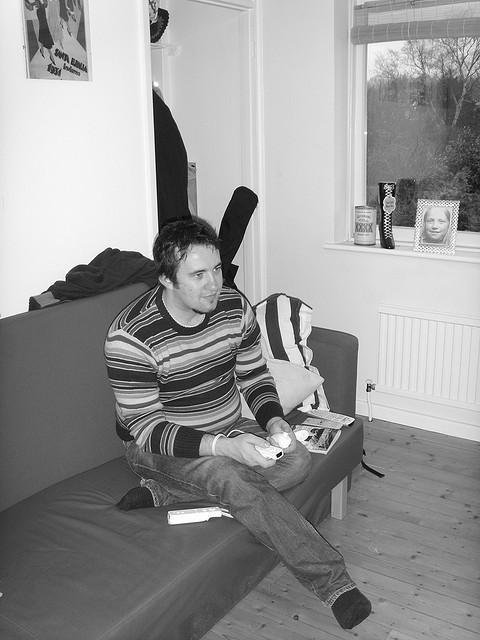How many people?
Give a very brief answer. 1. How many laptops are there?
Give a very brief answer. 0. 